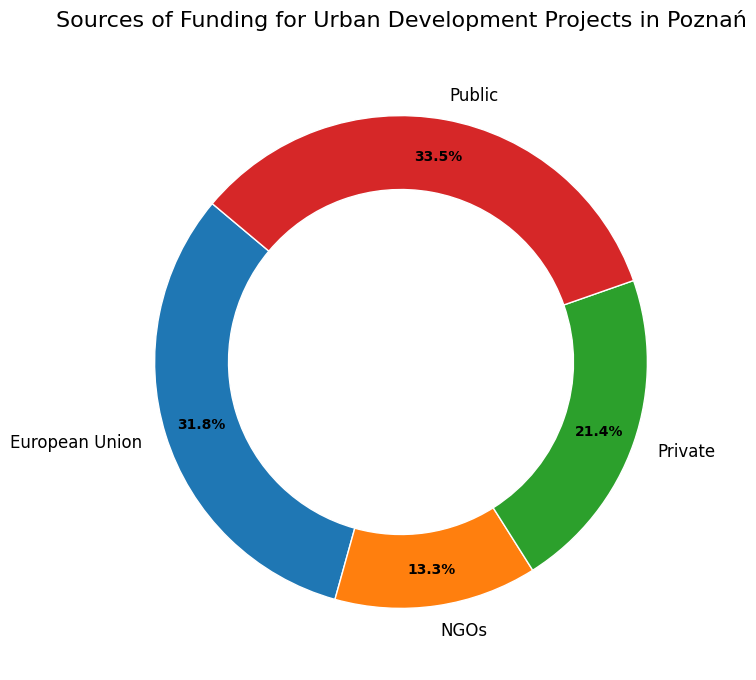What percentage of total funding comes from Public sources? To find the percentage of total funding from Public sources, look at the 'Public' slice in the ring chart. It shows 43.9%.
Answer: 43.9% How much more funding does Public get compared to Private? The figure shows that Public funding is higher than Private. The 'Public' slice is 43.9% while the 'Private' slice is 30.4%. To find the difference, subtract 30.4% from 43.9%. So, 43.9% - 30.4% = 13.5%.
Answer: 13.5% Which funding source contributes the least? The smallest slice in the ring chart represents the funding source that contributes the least. For this chart, it is labeled 'NGOs', which contributes 9.1%.
Answer: NGOs By how much does European Union funding surpass NGO funding? The European Union funding slice shows 38.5%, and the NGO funding slice shows 9.1%. Subtract the NGO funding percentage from the European Union funding percentage: 38.5% - 9.1% = 29.4%.
Answer: 29.4% What fraction of the total funding is provided by the European Union? The chart shows that the European Union provides 38.5% of the total funding. As a fraction, this can be represented as 38.5/100, which simplifies to 0.385.
Answer: 0.385 Which two funding sources combined contribute more than 50% of total funding? Adding the percentages of different funding sources, find two that sum to more than 50%. Public (43.9%) + NGOs (9.1%) = 53%. Public (43.9%) + European Union (38.5%) = 82.4%. Public and European Union together exceed 50%.
Answer: Public and European Union How does Private funding compare to NGO funding in terms of percentage contribution? Compare the percentages given in the figure for Private and NGO funding. Private is 30.4% and NGOs are 9.1%. Subtract NGO's percentage from Private's: 30.4% - 9.1% = 21.3%.
Answer: Private is 21.3% higher If Public funding were to decrease by 10%, what would its new percentage be? The current Public funding percentage is 43.9%. To find the new percentage after a 10% decrease, calculate 10% of 43.9% (which is 4.39%) and subtract it from 43.9%. So, 43.9% - 4.39% = 39.51%.
Answer: 39.51% 